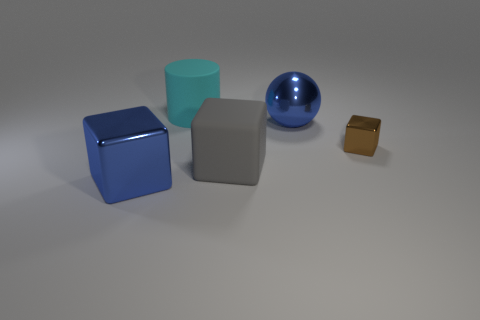The big metal object behind the shiny thing that is in front of the large block on the right side of the cyan matte object is what color?
Give a very brief answer. Blue. Are there any other things that have the same shape as the cyan matte thing?
Make the answer very short. No. Are there more gray matte cylinders than big cyan cylinders?
Ensure brevity in your answer.  No. How many objects are right of the large cyan rubber object and in front of the large shiny sphere?
Your answer should be very brief. 2. There is a metal cube right of the cyan cylinder; how many shiny blocks are behind it?
Offer a very short reply. 0. There is a cube behind the gray rubber object; is its size the same as the blue thing to the left of the cyan matte object?
Offer a terse response. No. What number of gray matte objects are there?
Ensure brevity in your answer.  1. How many big red cylinders are made of the same material as the brown block?
Make the answer very short. 0. Is the number of large blue spheres in front of the small metal cube the same as the number of big shiny objects?
Keep it short and to the point. No. What is the material of the block that is the same color as the large metallic ball?
Provide a short and direct response. Metal. 